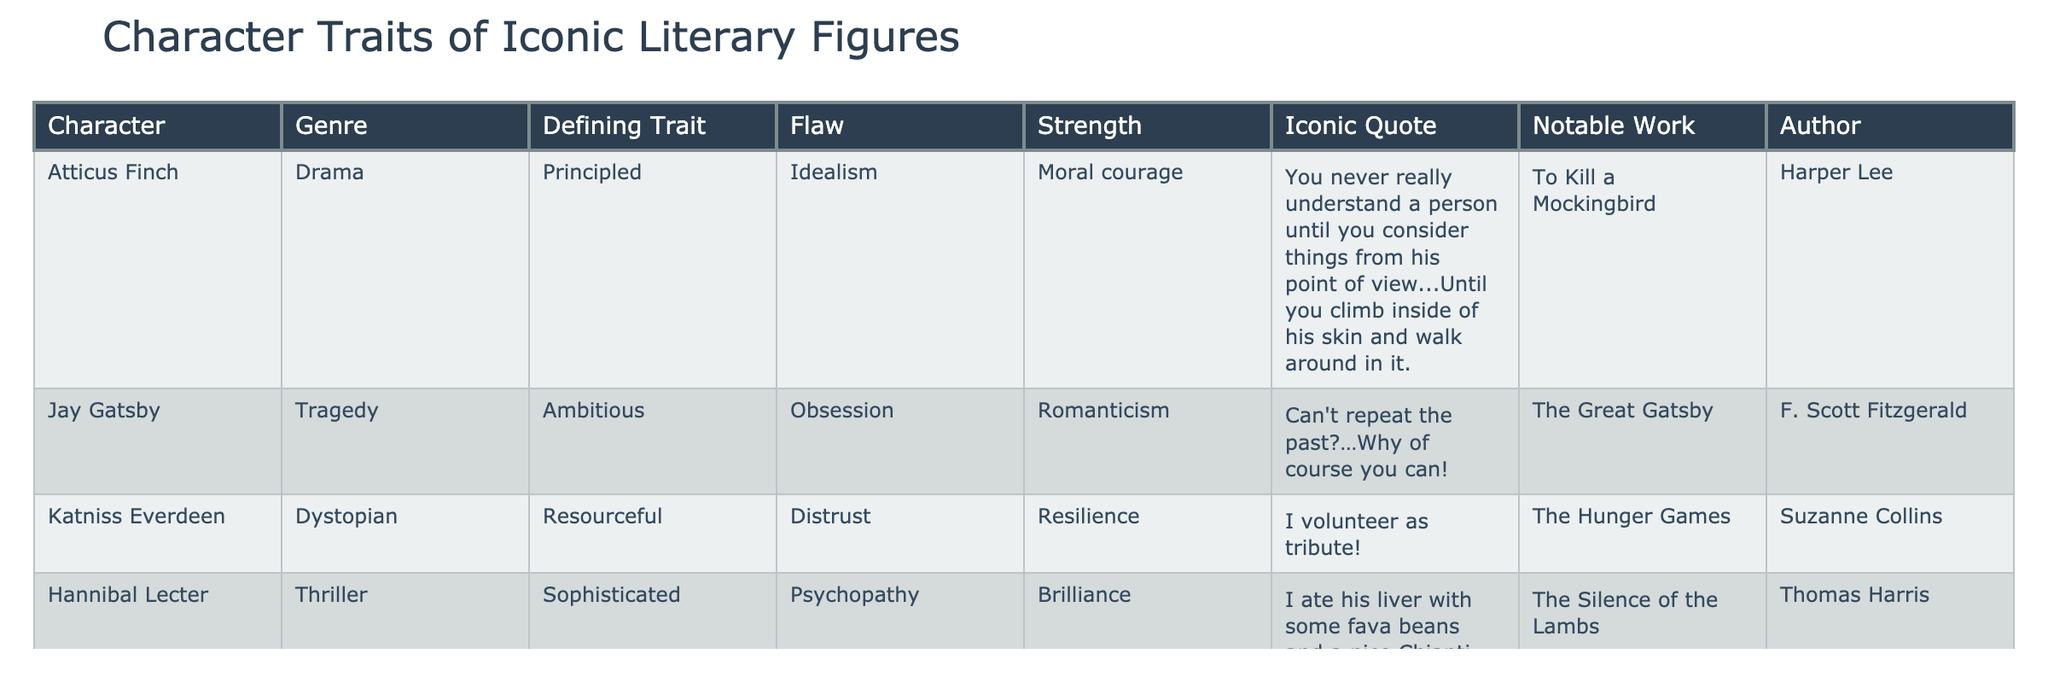What is the defining trait of Katniss Everdeen? According to the table, the defining trait of Katniss Everdeen is "Resourceful."
Answer: Resourceful Which character exhibits the flaw of greed? The table shows that Ebenezer Scrooge exhibits the flaw of "Greed."
Answer: Ebenezer Scrooge Name the notable work associated with Atticus Finch. The table lists "To Kill a Mockingbird" as the notable work for Atticus Finch.
Answer: To Kill a Mockingbird What are the strengths of Hannibal Lecter? The table indicates that Hannibal Lecter's strength is "Brilliance."
Answer: Brilliance Identify the author of "The Great Gatsby." The author listed in the table for "The Great Gatsby" is F. Scott Fitzgerald.
Answer: F. Scott Fitzgerald Are all characters depicted in the table from different genres? A quick review of the table shows that each character is from a distinct genre, confirming the statement is true.
Answer: True Which character has the defining trait of being principled and also shows idealism as a flaw? The table states that Atticus Finch has "Principled" as a defining trait and "Idealism" as a flaw.
Answer: Atticus Finch How many characters mentioned have a defining trait related to resourcefulness or resilience? Katniss Everdeen has "Resourceful," and although her resilience is a strength, she is the only one with a related defining trait. Thus, there is 1 character.
Answer: 1 Whose strength is described as "Moral courage"? The table attributes "Moral courage" as the strength of Atticus Finch.
Answer: Atticus Finch If you had to summarize in which genres the characters fall, how many are from dramatic or tragic genres? Atticus Finch (Drama) and Jay Gatsby (Tragedy) represent two genres. Hence, the sum is 2.
Answer: 2 